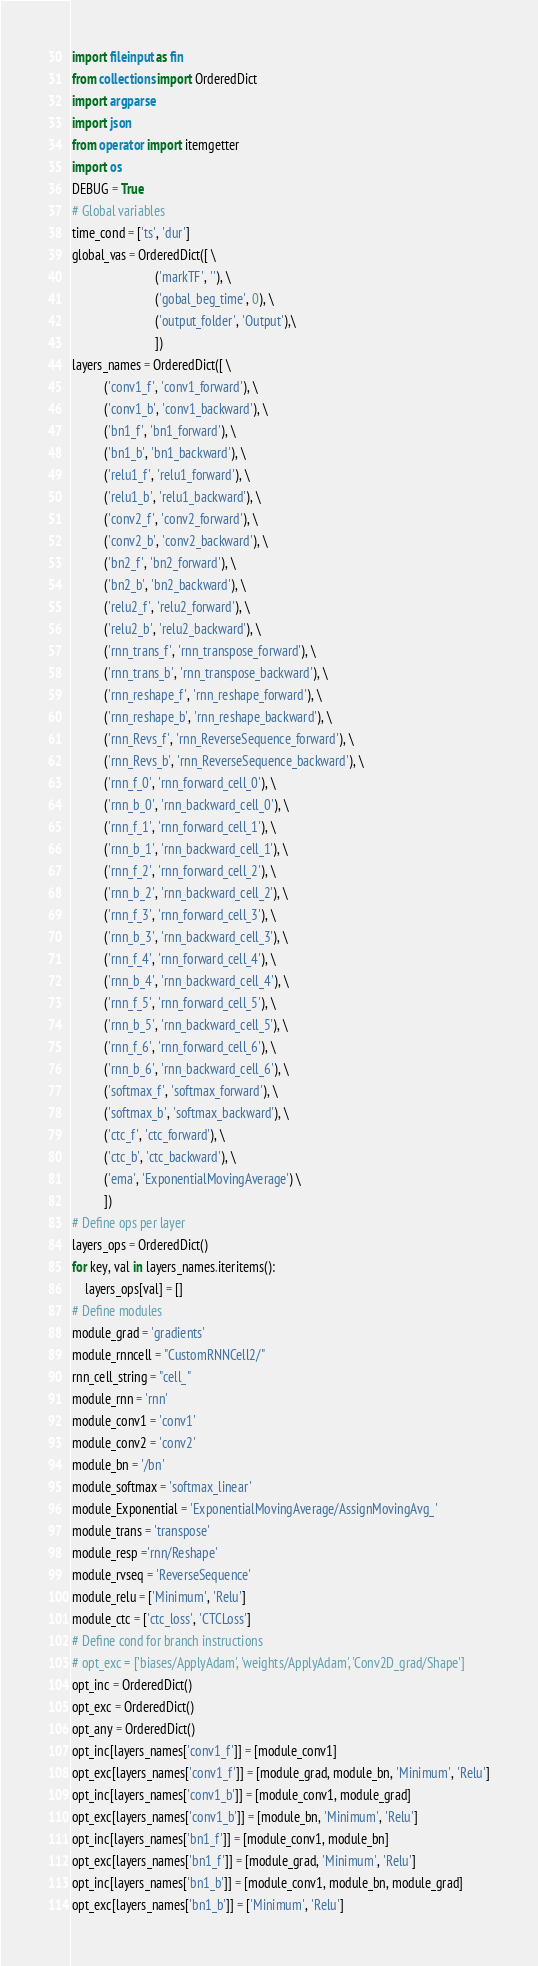<code> <loc_0><loc_0><loc_500><loc_500><_Python_>import fileinput as fin
from collections import OrderedDict
import argparse
import json
from operator import itemgetter
import os
DEBUG = True
# Global variables
time_cond = ['ts', 'dur']
global_vas = OrderedDict([ \
                          ('markTF', ''), \
                          ('gobal_beg_time', 0), \
                          ('output_folder', 'Output'),\
                          ])
layers_names = OrderedDict([ \
          ('conv1_f', 'conv1_forward'), \
          ('conv1_b', 'conv1_backward'), \
          ('bn1_f', 'bn1_forward'), \
          ('bn1_b', 'bn1_backward'), \
          ('relu1_f', 'relu1_forward'), \
          ('relu1_b', 'relu1_backward'), \
          ('conv2_f', 'conv2_forward'), \
          ('conv2_b', 'conv2_backward'), \
          ('bn2_f', 'bn2_forward'), \
          ('bn2_b', 'bn2_backward'), \
          ('relu2_f', 'relu2_forward'), \
          ('relu2_b', 'relu2_backward'), \
          ('rnn_trans_f', 'rnn_transpose_forward'), \
          ('rnn_trans_b', 'rnn_transpose_backward'), \
          ('rnn_reshape_f', 'rnn_reshape_forward'), \
          ('rnn_reshape_b', 'rnn_reshape_backward'), \
          ('rnn_Revs_f', 'rnn_ReverseSequence_forward'), \
          ('rnn_Revs_b', 'rnn_ReverseSequence_backward'), \
          ('rnn_f_0', 'rnn_forward_cell_0'), \
          ('rnn_b_0', 'rnn_backward_cell_0'), \
          ('rnn_f_1', 'rnn_forward_cell_1'), \
          ('rnn_b_1', 'rnn_backward_cell_1'), \
          ('rnn_f_2', 'rnn_forward_cell_2'), \
          ('rnn_b_2', 'rnn_backward_cell_2'), \
          ('rnn_f_3', 'rnn_forward_cell_3'), \
          ('rnn_b_3', 'rnn_backward_cell_3'), \
          ('rnn_f_4', 'rnn_forward_cell_4'), \
          ('rnn_b_4', 'rnn_backward_cell_4'), \
          ('rnn_f_5', 'rnn_forward_cell_5'), \
          ('rnn_b_5', 'rnn_backward_cell_5'), \
          ('rnn_f_6', 'rnn_forward_cell_6'), \
          ('rnn_b_6', 'rnn_backward_cell_6'), \
          ('softmax_f', 'softmax_forward'), \
          ('softmax_b', 'softmax_backward'), \
          ('ctc_f', 'ctc_forward'), \
          ('ctc_b', 'ctc_backward'), \
          ('ema', 'ExponentialMovingAverage') \
          ])
# Define ops per layer
layers_ops = OrderedDict()
for key, val in layers_names.iteritems():
    layers_ops[val] = []
# Define modules  
module_grad = 'gradients'
module_rnncell = "CustomRNNCell2/"
rnn_cell_string = "cell_"
module_rnn = 'rnn'
module_conv1 = 'conv1'
module_conv2 = 'conv2'
module_bn = '/bn'
module_softmax = 'softmax_linear'
module_Exponential = 'ExponentialMovingAverage/AssignMovingAvg_'
module_trans = 'transpose'
module_resp ='rnn/Reshape'
module_rvseq = 'ReverseSequence'
module_relu = ['Minimum', 'Relu']
module_ctc = ['ctc_loss', 'CTCLoss']
# Define cond for branch instructions
# opt_exc = ['biases/ApplyAdam', 'weights/ApplyAdam', 'Conv2D_grad/Shape']
opt_inc = OrderedDict()
opt_exc = OrderedDict()
opt_any = OrderedDict()
opt_inc[layers_names['conv1_f']] = [module_conv1]
opt_exc[layers_names['conv1_f']] = [module_grad, module_bn, 'Minimum', 'Relu']
opt_inc[layers_names['conv1_b']] = [module_conv1, module_grad]
opt_exc[layers_names['conv1_b']] = [module_bn, 'Minimum', 'Relu']
opt_inc[layers_names['bn1_f']] = [module_conv1, module_bn]
opt_exc[layers_names['bn1_f']] = [module_grad, 'Minimum', 'Relu']
opt_inc[layers_names['bn1_b']] = [module_conv1, module_bn, module_grad]
opt_exc[layers_names['bn1_b']] = ['Minimum', 'Relu']</code> 